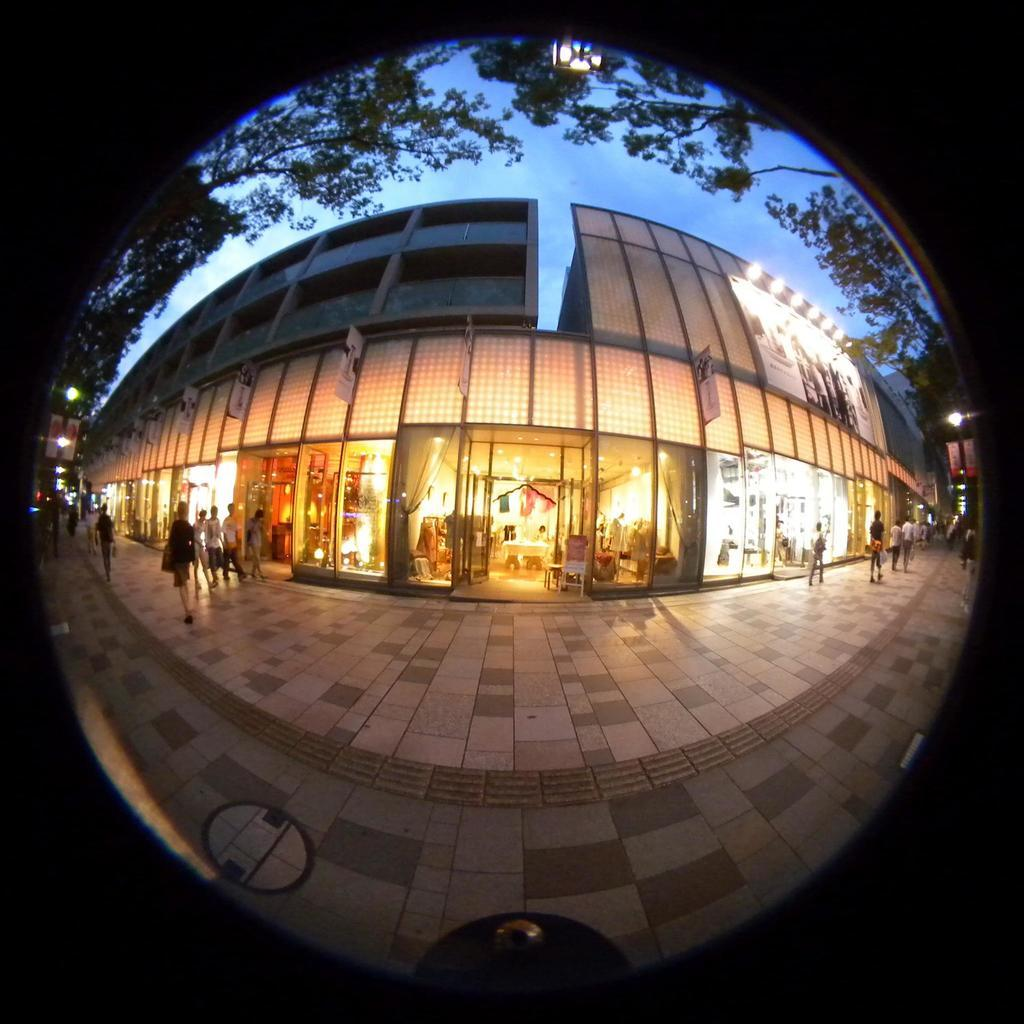What are the people in the image doing? There are persons walking in the image. What can be seen in the background of the image? There is a building and a store in the background of the image. What type of vegetation is present in the image? Trees are present at the top of the image. What is the condition of the sky in the image? The sky is clear and visible in the image. What type of tin can be seen in the image? There is no tin present in the image. What type of prose is being recited by the persons walking in the image? There is no indication of any prose being recited in the image. 